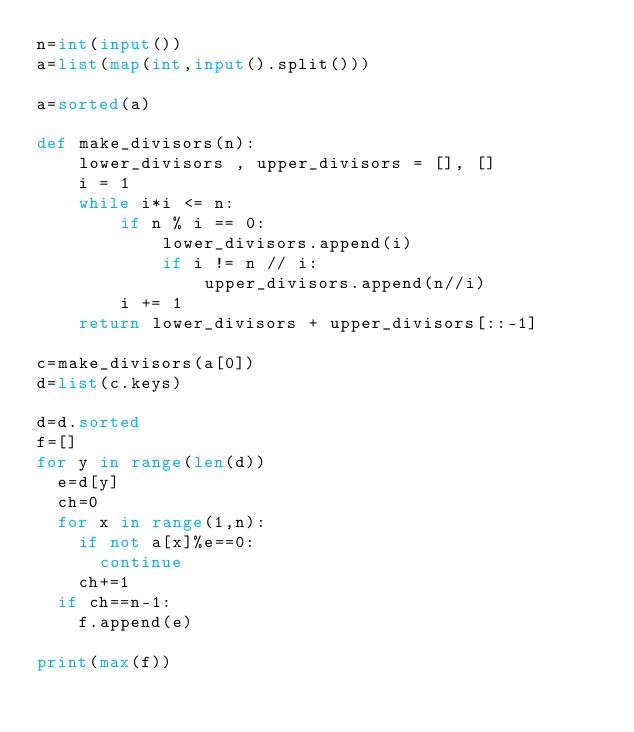<code> <loc_0><loc_0><loc_500><loc_500><_Python_>n=int(input())
a=list(map(int,input().split()))

a=sorted(a)

def make_divisors(n):
    lower_divisors , upper_divisors = [], []
    i = 1
    while i*i <= n:
        if n % i == 0:
            lower_divisors.append(i)
            if i != n // i:
                upper_divisors.append(n//i)
        i += 1
    return lower_divisors + upper_divisors[::-1]
  
c=make_divisors(a[0])
d=list(c.keys)

d=d.sorted
f=[]
for y in range(len(d))
  e=d[y]
  ch=0
  for x in range(1,n):
    if not a[x]%e==0:
      continue
    ch+=1
  if ch==n-1:
    f.append(e)
    
print(max(f))
    
      
     </code> 